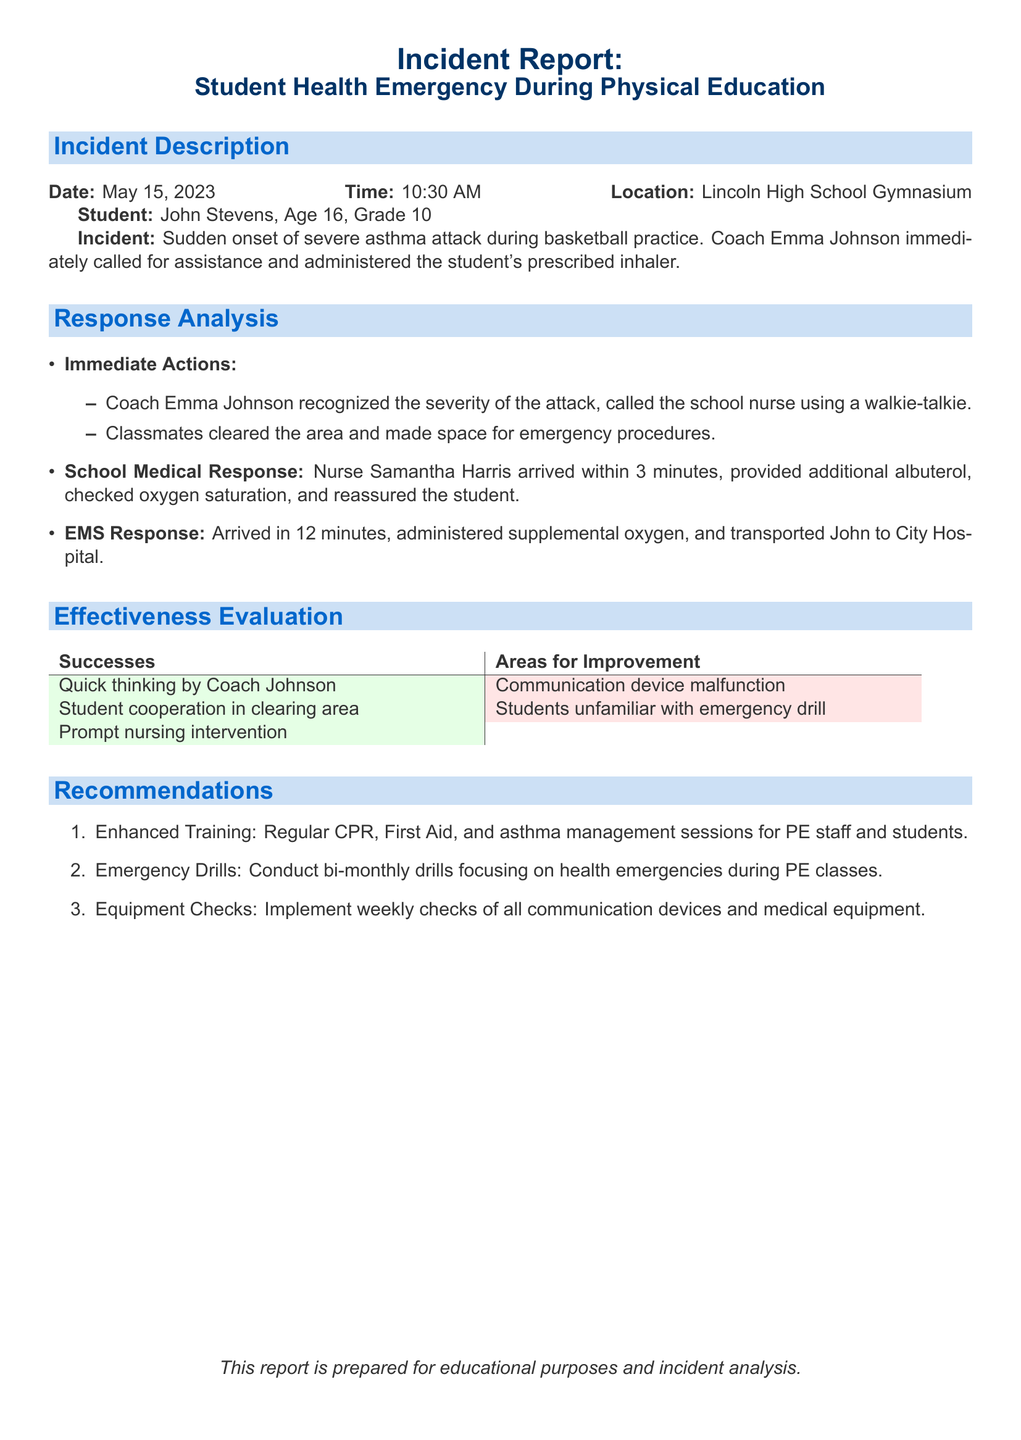What date did the incident occur? The incident date is specifically mentioned in the document under the incident description section.
Answer: May 15, 2023 Who administered the student's prescribed inhaler? This information is found in the description of immediate actions taken during the incident.
Answer: Coach Emma Johnson How old is the student involved in the incident? The student's age is stated in the incident description section.
Answer: 16 How long did it take for the school nurse to arrive? The time it took for the nurse's arrival is mentioned in the response analysis section.
Answer: 3 minutes What was one success noted in the effectiveness evaluation? The evaluation lists successes and areas for improvement related to the incident.
Answer: Quick thinking by Coach Johnson What improvement was highlighted in the effectiveness evaluation? The evaluation specifically mentions areas needing improvement.
Answer: Communication device malfunction How many recommendations are made in the report? The recommendations section enumerates the suggestions provided in the report.
Answer: 3 What does EMS stand for? The acronym EMS is mentioned in the context of the emergency response.
Answer: Emergency Medical Services In which location did the incident occur? The location of the incident is indicated in the incident description.
Answer: Lincoln High School Gymnasium 